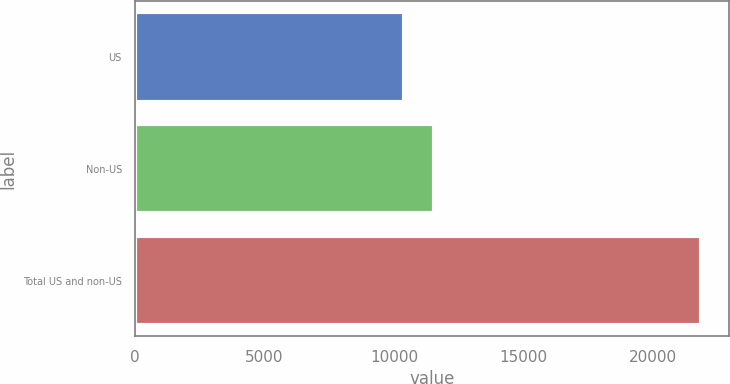<chart> <loc_0><loc_0><loc_500><loc_500><bar_chart><fcel>US<fcel>Non-US<fcel>Total US and non-US<nl><fcel>10397<fcel>11542.3<fcel>21850<nl></chart> 